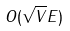<formula> <loc_0><loc_0><loc_500><loc_500>O ( \sqrt { V } E )</formula> 